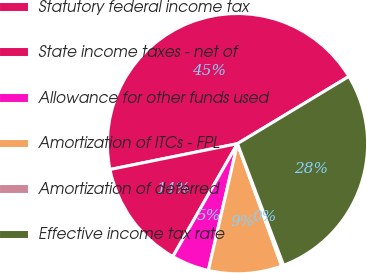Convert chart. <chart><loc_0><loc_0><loc_500><loc_500><pie_chart><fcel>Statutory federal income tax<fcel>State income taxes - net of<fcel>Allowance for other funds used<fcel>Amortization of ITCs - FPL<fcel>Amortization of deferred<fcel>Effective income tax rate<nl><fcel>44.54%<fcel>13.54%<fcel>4.68%<fcel>9.11%<fcel>0.25%<fcel>27.87%<nl></chart> 